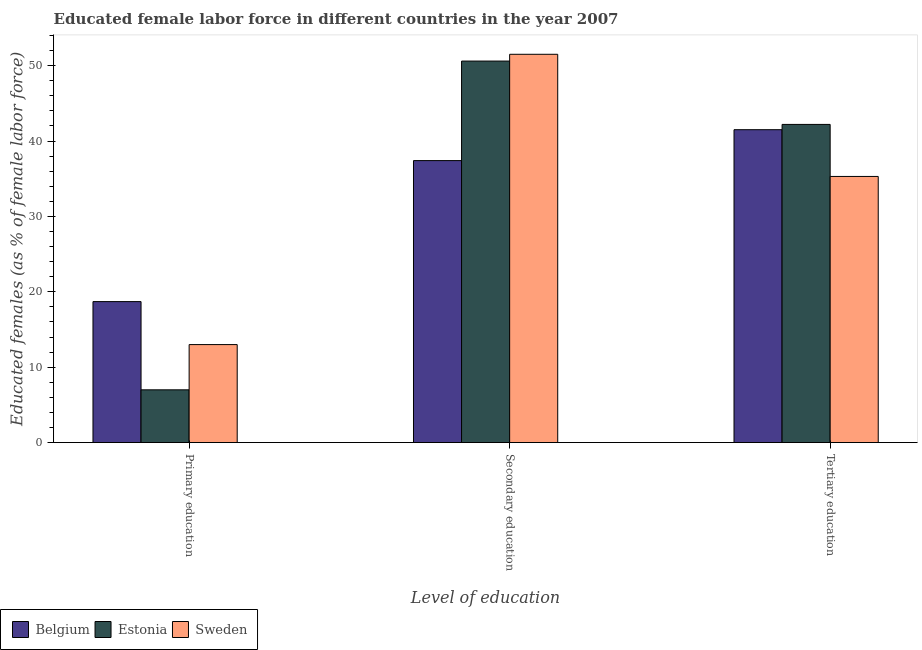How many groups of bars are there?
Provide a short and direct response. 3. Are the number of bars per tick equal to the number of legend labels?
Ensure brevity in your answer.  Yes. How many bars are there on the 3rd tick from the right?
Provide a short and direct response. 3. Across all countries, what is the maximum percentage of female labor force who received tertiary education?
Offer a very short reply. 42.2. Across all countries, what is the minimum percentage of female labor force who received tertiary education?
Make the answer very short. 35.3. In which country was the percentage of female labor force who received tertiary education maximum?
Your answer should be compact. Estonia. In which country was the percentage of female labor force who received primary education minimum?
Your answer should be very brief. Estonia. What is the total percentage of female labor force who received tertiary education in the graph?
Provide a succinct answer. 119. What is the difference between the percentage of female labor force who received secondary education in Sweden and that in Belgium?
Offer a terse response. 14.1. What is the difference between the percentage of female labor force who received secondary education in Estonia and the percentage of female labor force who received primary education in Sweden?
Make the answer very short. 37.6. What is the average percentage of female labor force who received secondary education per country?
Your response must be concise. 46.5. What is the difference between the percentage of female labor force who received tertiary education and percentage of female labor force who received primary education in Belgium?
Keep it short and to the point. 22.8. What is the ratio of the percentage of female labor force who received tertiary education in Estonia to that in Belgium?
Offer a very short reply. 1.02. Is the difference between the percentage of female labor force who received secondary education in Sweden and Belgium greater than the difference between the percentage of female labor force who received primary education in Sweden and Belgium?
Your answer should be very brief. Yes. What is the difference between the highest and the second highest percentage of female labor force who received tertiary education?
Make the answer very short. 0.7. What is the difference between the highest and the lowest percentage of female labor force who received secondary education?
Make the answer very short. 14.1. Is the sum of the percentage of female labor force who received tertiary education in Belgium and Sweden greater than the maximum percentage of female labor force who received secondary education across all countries?
Your answer should be compact. Yes. Is it the case that in every country, the sum of the percentage of female labor force who received primary education and percentage of female labor force who received secondary education is greater than the percentage of female labor force who received tertiary education?
Offer a terse response. Yes. How many bars are there?
Keep it short and to the point. 9. Are all the bars in the graph horizontal?
Keep it short and to the point. No. What is the difference between two consecutive major ticks on the Y-axis?
Make the answer very short. 10. Are the values on the major ticks of Y-axis written in scientific E-notation?
Keep it short and to the point. No. Does the graph contain grids?
Offer a very short reply. No. What is the title of the graph?
Your answer should be compact. Educated female labor force in different countries in the year 2007. Does "Sudan" appear as one of the legend labels in the graph?
Your response must be concise. No. What is the label or title of the X-axis?
Provide a succinct answer. Level of education. What is the label or title of the Y-axis?
Keep it short and to the point. Educated females (as % of female labor force). What is the Educated females (as % of female labor force) of Belgium in Primary education?
Provide a succinct answer. 18.7. What is the Educated females (as % of female labor force) of Estonia in Primary education?
Keep it short and to the point. 7. What is the Educated females (as % of female labor force) of Sweden in Primary education?
Make the answer very short. 13. What is the Educated females (as % of female labor force) in Belgium in Secondary education?
Offer a very short reply. 37.4. What is the Educated females (as % of female labor force) in Estonia in Secondary education?
Provide a succinct answer. 50.6. What is the Educated females (as % of female labor force) in Sweden in Secondary education?
Your answer should be compact. 51.5. What is the Educated females (as % of female labor force) of Belgium in Tertiary education?
Your answer should be compact. 41.5. What is the Educated females (as % of female labor force) in Estonia in Tertiary education?
Provide a succinct answer. 42.2. What is the Educated females (as % of female labor force) of Sweden in Tertiary education?
Offer a very short reply. 35.3. Across all Level of education, what is the maximum Educated females (as % of female labor force) in Belgium?
Offer a terse response. 41.5. Across all Level of education, what is the maximum Educated females (as % of female labor force) of Estonia?
Your response must be concise. 50.6. Across all Level of education, what is the maximum Educated females (as % of female labor force) in Sweden?
Offer a very short reply. 51.5. Across all Level of education, what is the minimum Educated females (as % of female labor force) in Belgium?
Ensure brevity in your answer.  18.7. Across all Level of education, what is the minimum Educated females (as % of female labor force) of Estonia?
Your answer should be compact. 7. Across all Level of education, what is the minimum Educated females (as % of female labor force) in Sweden?
Give a very brief answer. 13. What is the total Educated females (as % of female labor force) of Belgium in the graph?
Offer a very short reply. 97.6. What is the total Educated females (as % of female labor force) in Estonia in the graph?
Ensure brevity in your answer.  99.8. What is the total Educated females (as % of female labor force) of Sweden in the graph?
Offer a very short reply. 99.8. What is the difference between the Educated females (as % of female labor force) in Belgium in Primary education and that in Secondary education?
Give a very brief answer. -18.7. What is the difference between the Educated females (as % of female labor force) in Estonia in Primary education and that in Secondary education?
Keep it short and to the point. -43.6. What is the difference between the Educated females (as % of female labor force) in Sweden in Primary education and that in Secondary education?
Ensure brevity in your answer.  -38.5. What is the difference between the Educated females (as % of female labor force) in Belgium in Primary education and that in Tertiary education?
Your response must be concise. -22.8. What is the difference between the Educated females (as % of female labor force) of Estonia in Primary education and that in Tertiary education?
Your answer should be very brief. -35.2. What is the difference between the Educated females (as % of female labor force) of Sweden in Primary education and that in Tertiary education?
Offer a terse response. -22.3. What is the difference between the Educated females (as % of female labor force) in Belgium in Primary education and the Educated females (as % of female labor force) in Estonia in Secondary education?
Your answer should be compact. -31.9. What is the difference between the Educated females (as % of female labor force) in Belgium in Primary education and the Educated females (as % of female labor force) in Sweden in Secondary education?
Your answer should be compact. -32.8. What is the difference between the Educated females (as % of female labor force) of Estonia in Primary education and the Educated females (as % of female labor force) of Sweden in Secondary education?
Your answer should be very brief. -44.5. What is the difference between the Educated females (as % of female labor force) of Belgium in Primary education and the Educated females (as % of female labor force) of Estonia in Tertiary education?
Provide a succinct answer. -23.5. What is the difference between the Educated females (as % of female labor force) in Belgium in Primary education and the Educated females (as % of female labor force) in Sweden in Tertiary education?
Offer a very short reply. -16.6. What is the difference between the Educated females (as % of female labor force) in Estonia in Primary education and the Educated females (as % of female labor force) in Sweden in Tertiary education?
Provide a short and direct response. -28.3. What is the difference between the Educated females (as % of female labor force) of Belgium in Secondary education and the Educated females (as % of female labor force) of Sweden in Tertiary education?
Provide a short and direct response. 2.1. What is the average Educated females (as % of female labor force) of Belgium per Level of education?
Offer a very short reply. 32.53. What is the average Educated females (as % of female labor force) of Estonia per Level of education?
Ensure brevity in your answer.  33.27. What is the average Educated females (as % of female labor force) of Sweden per Level of education?
Offer a terse response. 33.27. What is the difference between the Educated females (as % of female labor force) of Belgium and Educated females (as % of female labor force) of Estonia in Primary education?
Your answer should be very brief. 11.7. What is the difference between the Educated females (as % of female labor force) in Belgium and Educated females (as % of female labor force) in Estonia in Secondary education?
Your answer should be compact. -13.2. What is the difference between the Educated females (as % of female labor force) in Belgium and Educated females (as % of female labor force) in Sweden in Secondary education?
Offer a terse response. -14.1. What is the difference between the Educated females (as % of female labor force) of Estonia and Educated females (as % of female labor force) of Sweden in Tertiary education?
Offer a terse response. 6.9. What is the ratio of the Educated females (as % of female labor force) in Belgium in Primary education to that in Secondary education?
Your response must be concise. 0.5. What is the ratio of the Educated females (as % of female labor force) of Estonia in Primary education to that in Secondary education?
Your answer should be very brief. 0.14. What is the ratio of the Educated females (as % of female labor force) in Sweden in Primary education to that in Secondary education?
Ensure brevity in your answer.  0.25. What is the ratio of the Educated females (as % of female labor force) of Belgium in Primary education to that in Tertiary education?
Offer a very short reply. 0.45. What is the ratio of the Educated females (as % of female labor force) of Estonia in Primary education to that in Tertiary education?
Your answer should be compact. 0.17. What is the ratio of the Educated females (as % of female labor force) of Sweden in Primary education to that in Tertiary education?
Provide a short and direct response. 0.37. What is the ratio of the Educated females (as % of female labor force) in Belgium in Secondary education to that in Tertiary education?
Make the answer very short. 0.9. What is the ratio of the Educated females (as % of female labor force) in Estonia in Secondary education to that in Tertiary education?
Give a very brief answer. 1.2. What is the ratio of the Educated females (as % of female labor force) in Sweden in Secondary education to that in Tertiary education?
Provide a succinct answer. 1.46. What is the difference between the highest and the second highest Educated females (as % of female labor force) of Belgium?
Keep it short and to the point. 4.1. What is the difference between the highest and the second highest Educated females (as % of female labor force) of Estonia?
Offer a very short reply. 8.4. What is the difference between the highest and the second highest Educated females (as % of female labor force) in Sweden?
Your answer should be compact. 16.2. What is the difference between the highest and the lowest Educated females (as % of female labor force) in Belgium?
Ensure brevity in your answer.  22.8. What is the difference between the highest and the lowest Educated females (as % of female labor force) in Estonia?
Offer a terse response. 43.6. What is the difference between the highest and the lowest Educated females (as % of female labor force) of Sweden?
Your response must be concise. 38.5. 